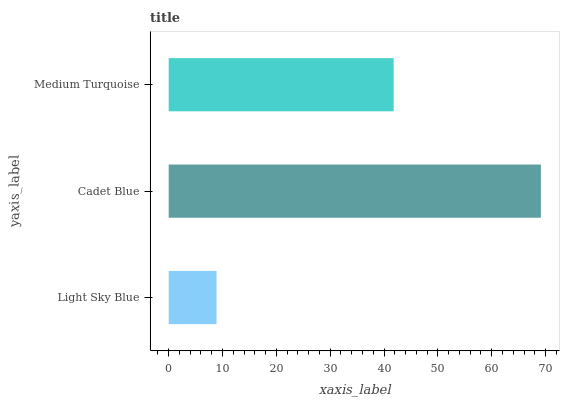Is Light Sky Blue the minimum?
Answer yes or no. Yes. Is Cadet Blue the maximum?
Answer yes or no. Yes. Is Medium Turquoise the minimum?
Answer yes or no. No. Is Medium Turquoise the maximum?
Answer yes or no. No. Is Cadet Blue greater than Medium Turquoise?
Answer yes or no. Yes. Is Medium Turquoise less than Cadet Blue?
Answer yes or no. Yes. Is Medium Turquoise greater than Cadet Blue?
Answer yes or no. No. Is Cadet Blue less than Medium Turquoise?
Answer yes or no. No. Is Medium Turquoise the high median?
Answer yes or no. Yes. Is Medium Turquoise the low median?
Answer yes or no. Yes. Is Cadet Blue the high median?
Answer yes or no. No. Is Light Sky Blue the low median?
Answer yes or no. No. 